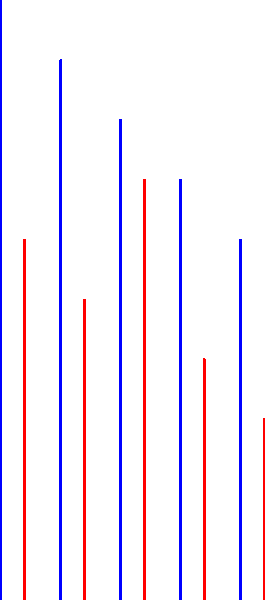Based on the chart comparing win records before and after key players left through the transfer portal, which team experienced the smallest decline in performance? To determine which team experienced the smallest decline in performance, we need to calculate the difference between wins before and after the transfer for each team:

1. Team A: $10 - 6 = 4$ wins decline
2. Team B: $9 - 5 = 4$ wins decline
3. Team C: $8 - 7 = 1$ win decline
4. Team D: $7 - 4 = 3$ wins decline
5. Team E: $6 - 3 = 3$ wins decline

The smallest decline is 1 win, which occurred for Team C.
Answer: Team C 